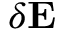<formula> <loc_0><loc_0><loc_500><loc_500>\delta E</formula> 